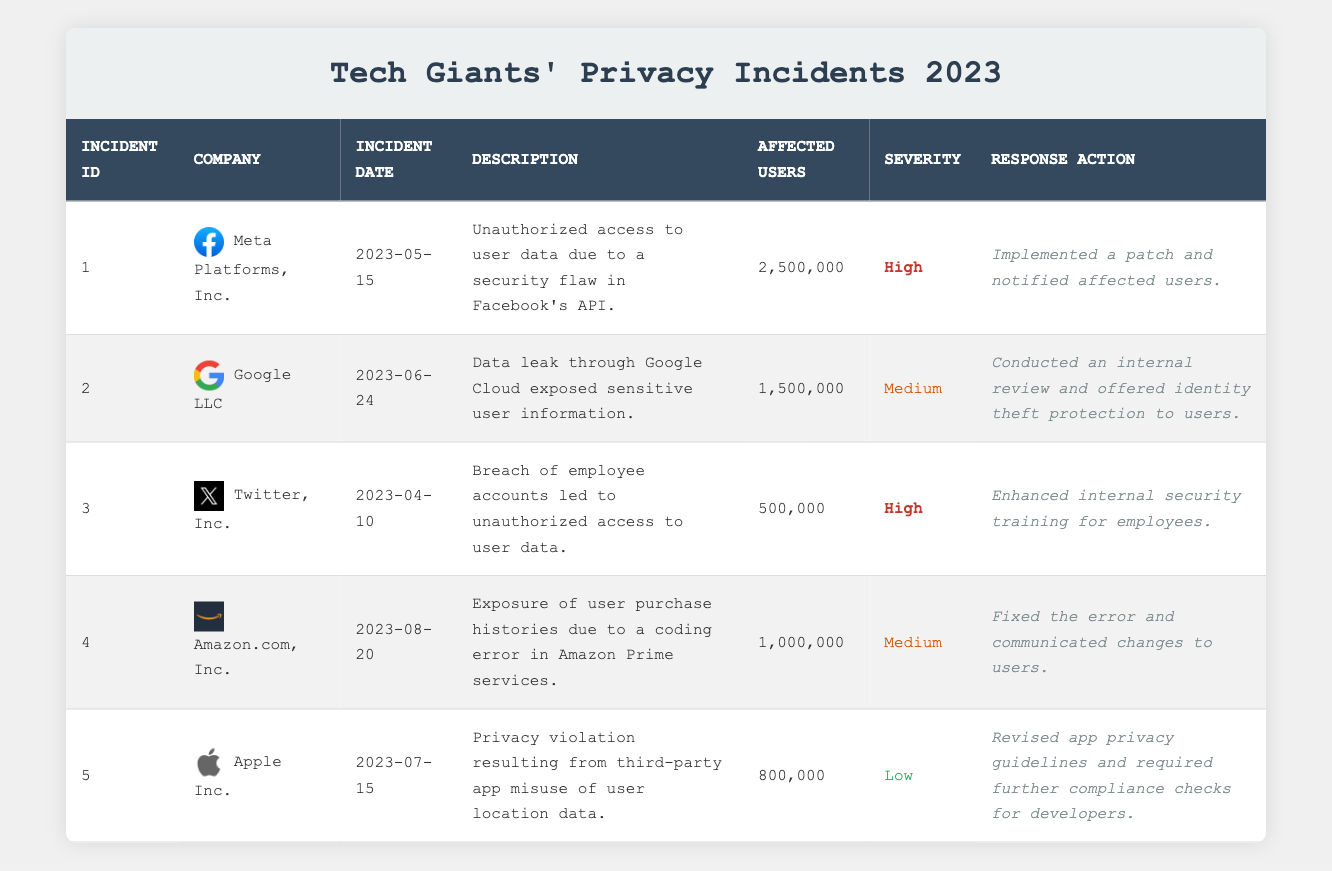What company reported the highest number of affected users? By reviewing the "Number of Affected Users" column, Meta Platforms, Inc. is listed with 2,500,000 affected users, which is the highest among all companies in the table.
Answer: Meta Platforms, Inc How many incidents had a severity rated as high? Scanning the "Severity" column, there are two incidents labeled as "High": one incident from Meta Platforms, Inc. and another from Twitter, Inc. Thus, the count is 2.
Answer: 2 What was the total number of affected users across all reported incidents? To find the total, sum the affected users: 2,500,000 (Meta) + 1,500,000 (Google) + 500,000 (Twitter) + 1,000,000 (Amazon) + 800,000 (Apple) = 6,300,000.
Answer: 6,300,000 Did Google LLC implement security training for employees following its data incident? In the "Response Action" column for Google LLC, it states that they conducted an internal review, but there is no mention of security training for employees. Therefore, the answer is no.
Answer: No Which company experienced a privacy violation related to third-party applications? Looking through the "Description" column, it indicates that Apple Inc. faced a privacy violation resulting from third-party app misuse of user location data. Thus, the answer is Apple Inc.
Answer: Apple Inc What were the responses taken by companies that reported medium severity incidents? The table shows that Google LLC conducted an internal review and offered identity theft protection, whereas Amazon.com, Inc. fixed the coding error and communicated changes to users. Therefore, both companies took proactive measures.
Answer: Google and Amazon How many incidents occurred after June 2023? Scanning the "Incident Date" column, incidents 4 and 5 (Amazon and Apple) occurred after June 2023. Thus, there are 2 incidents that fit this criteria.
Answer: 2 What was the incident description for the date 2023-08-20? Referring to the "Incident Date" of 2023-08-20, the description states that there was an exposure of user purchase histories due to a coding error in Amazon Prime services.
Answer: Exposure of user purchase histories due to a coding error Which tech company’s incident involved a security flaw in their API? By checking the "Description" column, Meta Platforms, Inc. had an incident described as unauthorized access to user data due to a security flaw in Facebook's API. Thus, it specifically refers to Meta Platforms, Inc.
Answer: Meta Platforms, Inc 